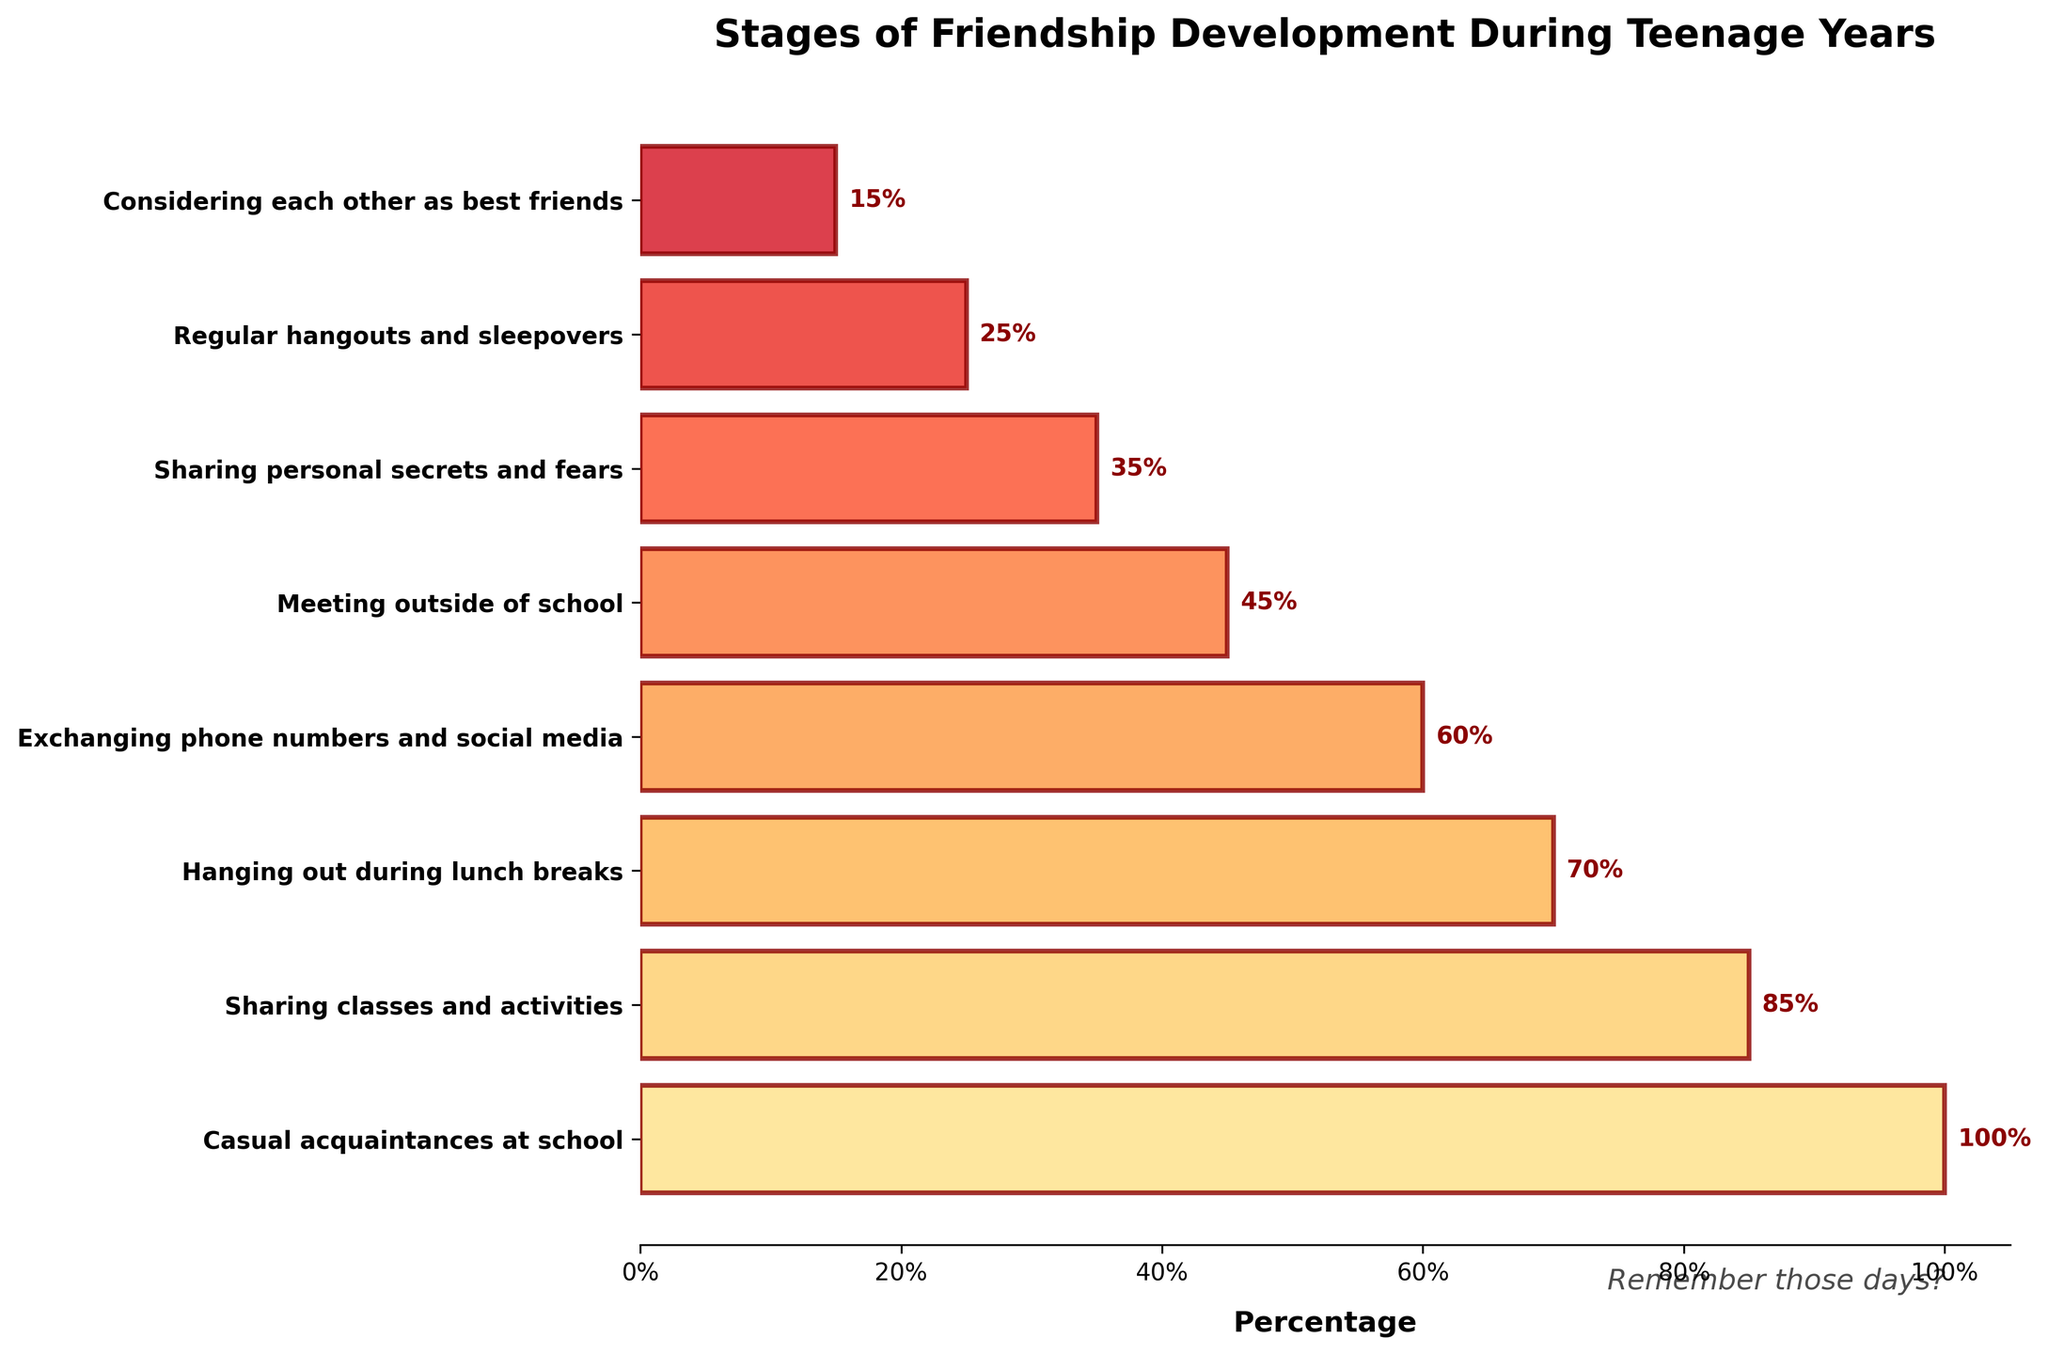What's the title of the plot? The title of the plot is located at the top. It reads 'Stages of Friendship Development During Teenage Years'.
Answer: Stages of Friendship Development During Teenage Years How many friendship development stages are displayed on the plot? There are several stages displayed in the form of horizontal bars. Counting these bars, we get a total of 8 stages.
Answer: 8 Which stage represents the smallest percentage of friendship development? The smallest percentage can be found at the bottom of the funnel. This stage is 'Considering each other as best friends' with 15%.
Answer: Considering each other as best friends What is the percentage difference between 'Sharing personal secrets and fears' and 'Meeting outside of school'? The percentage for 'Sharing personal secrets and fears' is 35%, and for 'Meeting outside of school' is 45%. The difference is 45% - 35% = 10%.
Answer: 10% Which two stages have percentages that differ by exactly 10%? Scanning the percentages given in the funnel, 'Meeting outside of school' (45%) and 'Sharing personal secrets and fears' (35%) differ by 10%.
Answer: Meeting outside of school and Sharing personal secrets and fears What is the approximate average percentage of the stages displayed? Adding up all the percentages: 100% + 85% + 70% + 60% + 45% + 35% + 25% + 15% = 435%. Dividing by the number of stages, 435% / 8 ≈ 54.38%.
Answer: 54.38% Which stage follows 'Exchanging phone numbers and social media'? After 'Exchanging phone numbers and social media' (60%), the next stage in the funnel is 'Meeting outside of school' (45%).
Answer: Meeting outside of school How much higher is the percentage of 'Casual acquaintances at school' compared to 'Considering each other as best friends'? 'Casual acquaintances at school' is 100%, and 'Considering each other as best friends' is 15%. The difference is 100% - 15% = 85%.
Answer: 85% What percentage of people exchanged phone numbers and social media? The figure shows the stage 'Exchanging phone numbers and social media' with a corresponding bar indicating 60%.
Answer: 60% At which stage do regular hangouts and sleepovers commonly happen? The funnel shows 'Regular hangouts and sleepovers' with a percentage of 25%.
Answer: 25% 